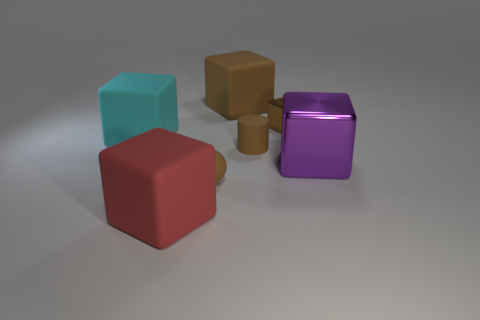Subtract all shiny cubes. How many cubes are left? 3 Add 2 big red matte objects. How many objects exist? 9 Subtract all brown blocks. How many blocks are left? 3 Subtract all red cylinders. Subtract all purple shiny cubes. How many objects are left? 6 Add 4 tiny brown shiny things. How many tiny brown shiny things are left? 5 Add 3 small spheres. How many small spheres exist? 4 Subtract 0 gray cubes. How many objects are left? 7 Subtract all balls. How many objects are left? 6 Subtract 3 blocks. How many blocks are left? 2 Subtract all blue cylinders. Subtract all brown cubes. How many cylinders are left? 1 